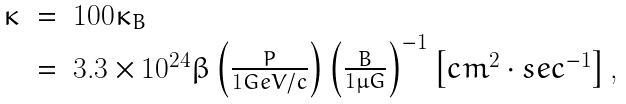Convert formula to latex. <formula><loc_0><loc_0><loc_500><loc_500>\begin{array} { l l l l } \kappa & = & 1 0 0 { \kappa } _ { B } \\ & = & 3 . 3 \times 1 0 ^ { 2 4 } \beta \left ( \frac { P } { 1 G e V / c } \right ) \left ( \frac { B } { 1 \mu G } \right ) ^ { - 1 } \left [ c m ^ { 2 } \cdot s e c ^ { - 1 } \right ] , \end{array}</formula> 